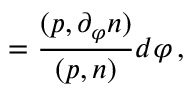Convert formula to latex. <formula><loc_0><loc_0><loc_500><loc_500>{ \Omega } = \frac { ( p , \partial _ { \varphi } n ) } { ( p , n ) } d \varphi \, ,</formula> 